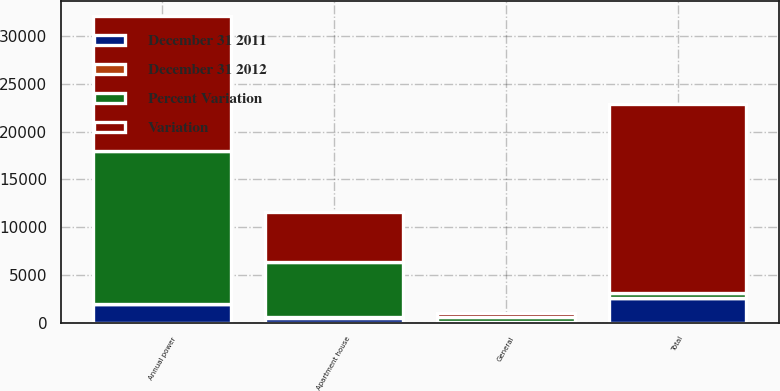<chart> <loc_0><loc_0><loc_500><loc_500><stacked_bar_chart><ecel><fcel>General<fcel>Apartment house<fcel>Annual power<fcel>Total<nl><fcel>Variation<fcel>425<fcel>5240<fcel>14076<fcel>19741<nl><fcel>Percent Variation<fcel>519<fcel>5779<fcel>16024<fcel>539<nl><fcel>December 31 2011<fcel>94<fcel>539<fcel>1948<fcel>2581<nl><fcel>December 31 2012<fcel>18.1<fcel>9.3<fcel>12.2<fcel>11.6<nl></chart> 